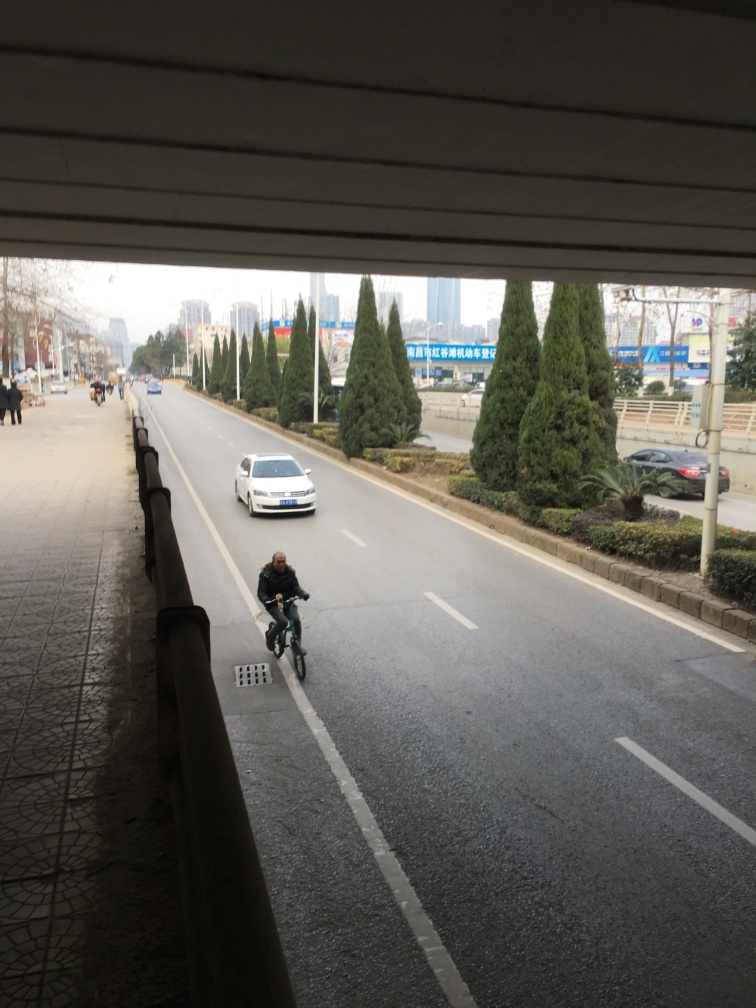What time of day does this photo look like it was taken? Based on the lighting and the length of the shadows, it seems like it could be late morning or early afternoon. 